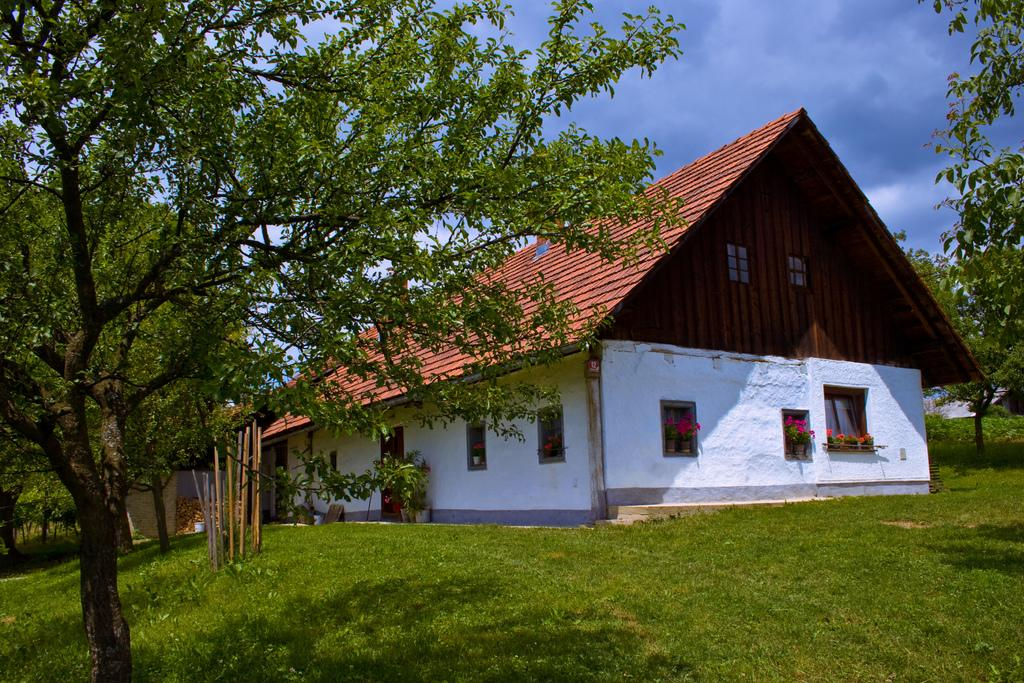What type of structure is visible in the image? There is a house in the image. What can be seen on both sides of the house? There are trees on either side of the house. What is the ground covered with in the image? The ground is covered in greenery. What is the condition of the sky in the image? The sky is cloudy in the image. What page of the stranger's notebook is visible in the image? There is no stranger or notebook present in the image. 